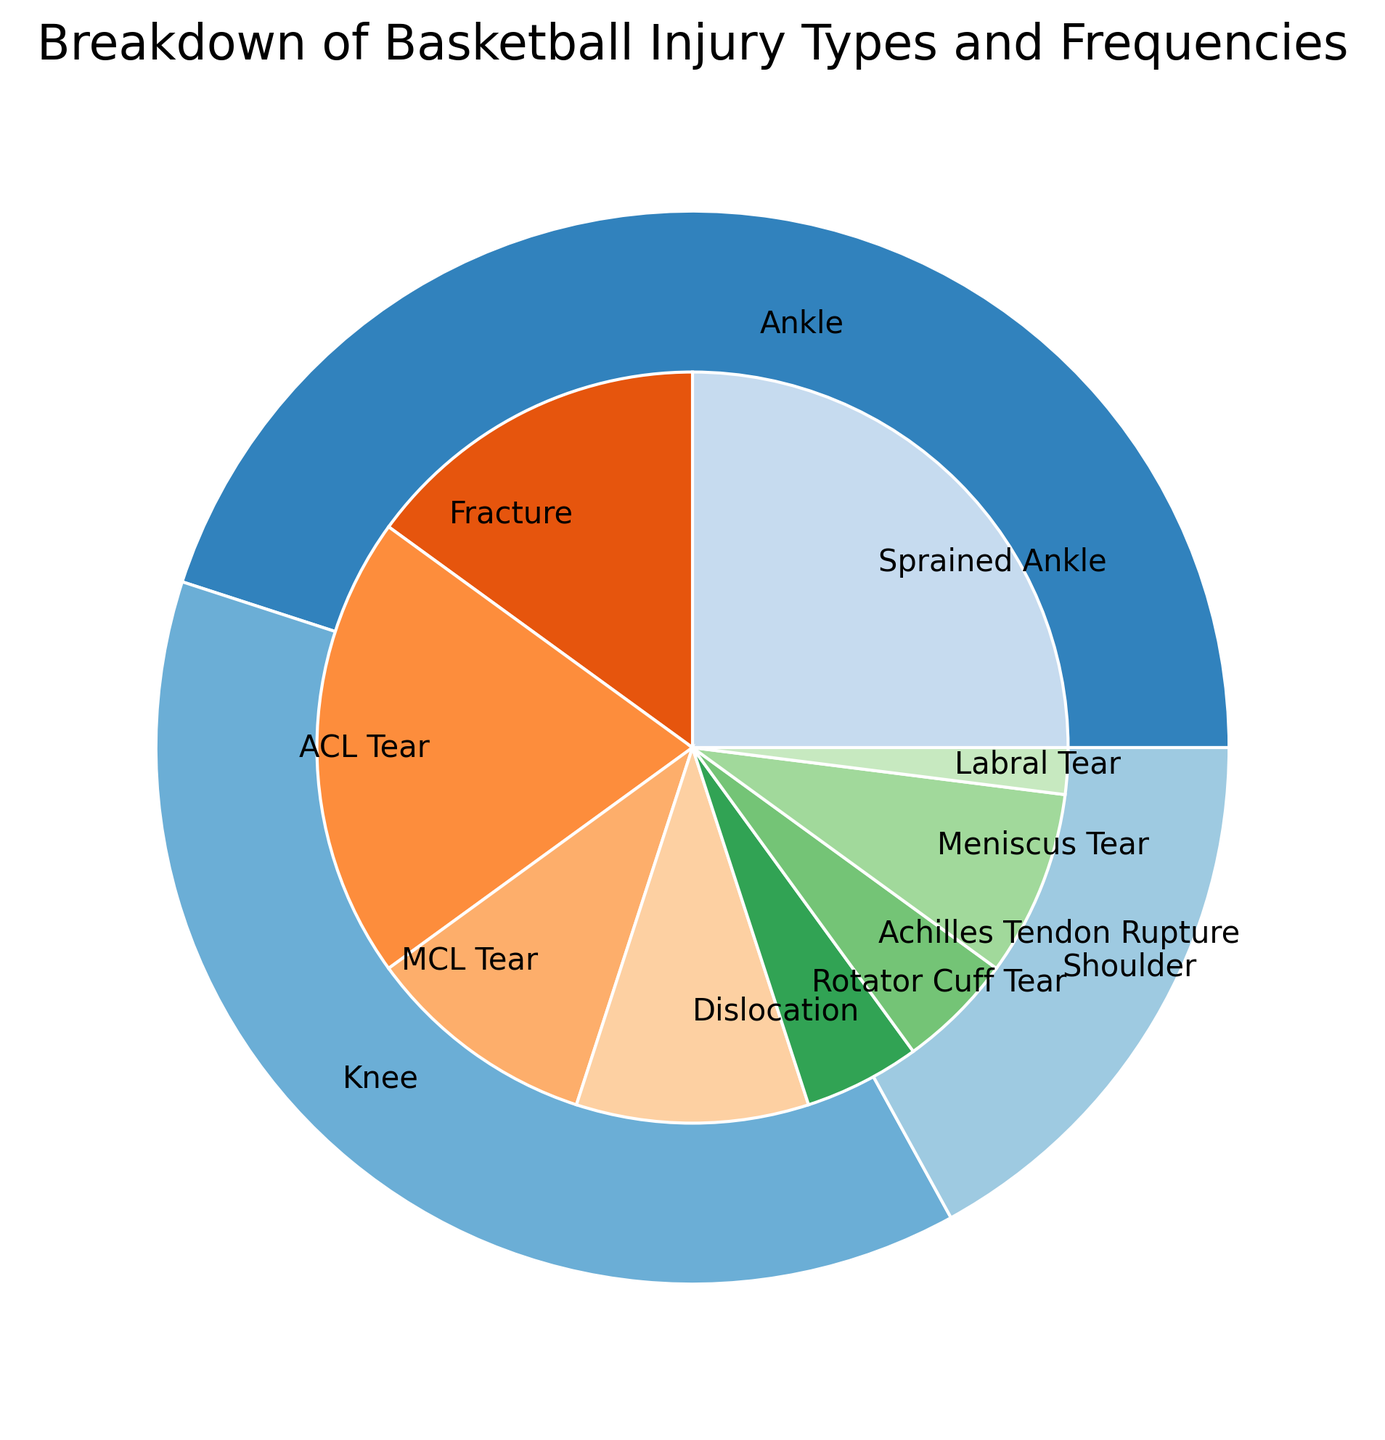Which injury type has the highest frequency? The pie chart shows different categories and injury types with their respective percentages. The largest segment in terms of frequency is for Sprained Ankle with 25%.
Answer: Sprained Ankle How does the recovery time for a Rotator Cuff Tear compare to an ACL Tear? The average recovery time for Rotator Cuff Tear is 20 weeks, and for ACL Tear, it's 30 weeks. By comparing these times, ACL Tear has a longer recovery period.
Answer: ACL Tear has a longer recovery period What's the total percentage of knee-related injuries? Add the percentages for ACL Tear (20%), MCL Tear (10%), and Meniscus Tear (8%). Summing up these percentages: 20 + 10 + 8 = 38%.
Answer: 38% Which injury in the Shoulder category has the shortest recovery time? In the Shoulder category, comparing the recovery times: Dislocation (6 weeks), Rotator Cuff Tear (20 weeks), and Labral Tear (12 weeks), Dislocation has the shortest recovery time.
Answer: Dislocation Is the percentage of Achilles Tendon Rupture injuries greater than Labral Tear injuries? Achilles Tendon Rupture has a 5% frequency, while Labral Tear has 2%. By comparing these figures, 5% is greater than 2%.
Answer: Yes What is the recovery time range for Ankle injuries? Assessing the recovery times for Ankle injuries: Sprained Ankle (4 weeks), Fracture (8 weeks), and Achilles Tendon Rupture (24 weeks). The minimum is 4 weeks, and the maximum is 24 weeks.
Answer: 4 to 24 weeks How many injury types fall under the Knee category and how does it compare visually to Ankle injuries? There are three types of injuries in the Knee category: ACL Tear (20%), MCL Tear (10%), and Meniscus Tear (8%). There are three types in Ankle as well: Sprained Ankle (25%), Fracture (15%), and Achilles Tendon Rupture (5%). Visually, Ankle injuries are larger due to higher percentages for Sprained Ankle and Fracture compared to Knee injuries.
Answer: Knee has 3 types, visually smaller What is the average recovery time for Shoulder-related injuries? To find the average recovery time: Dislocation (6 weeks), Rotator Cuff Tear (20 weeks), and Labral Tear (12 weeks). Calculation: (6 + 20 + 12)/3 = 38/3 ≈ 12.67 weeks
Answer: Approximately 12.67 weeks 